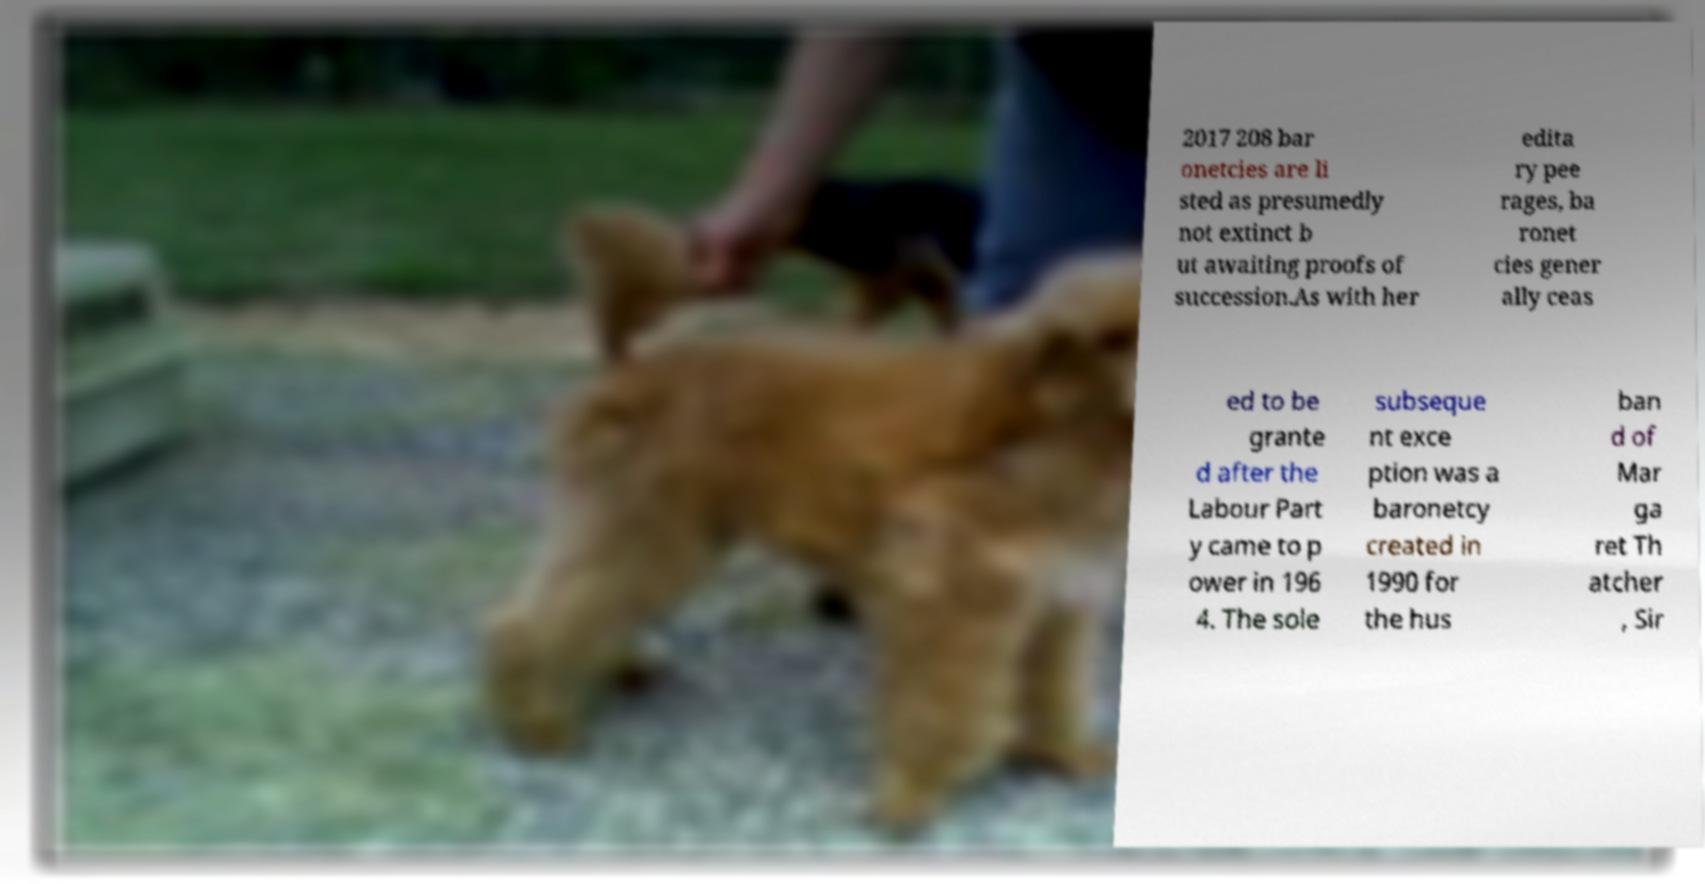Can you accurately transcribe the text from the provided image for me? 2017 208 bar onetcies are li sted as presumedly not extinct b ut awaiting proofs of succession.As with her edita ry pee rages, ba ronet cies gener ally ceas ed to be grante d after the Labour Part y came to p ower in 196 4. The sole subseque nt exce ption was a baronetcy created in 1990 for the hus ban d of Mar ga ret Th atcher , Sir 